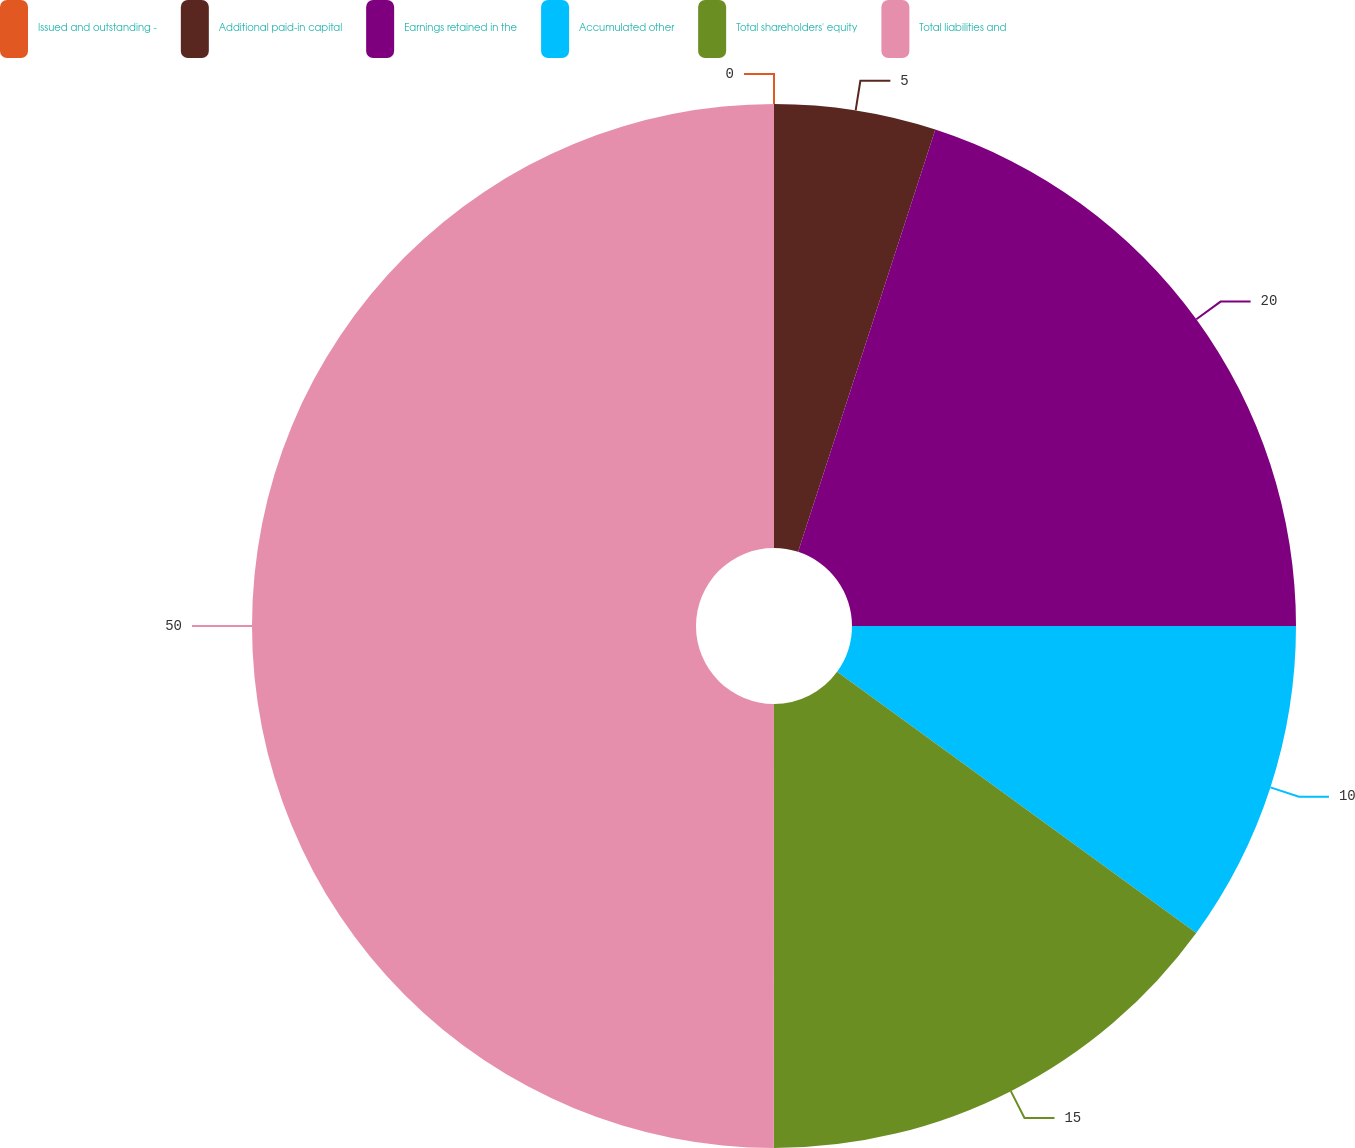<chart> <loc_0><loc_0><loc_500><loc_500><pie_chart><fcel>Issued and outstanding -<fcel>Additional paid-in capital<fcel>Earnings retained in the<fcel>Accumulated other<fcel>Total shareholders' equity<fcel>Total liabilities and<nl><fcel>0.0%<fcel>5.0%<fcel>20.0%<fcel>10.0%<fcel>15.0%<fcel>49.99%<nl></chart> 